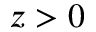<formula> <loc_0><loc_0><loc_500><loc_500>z > 0</formula> 